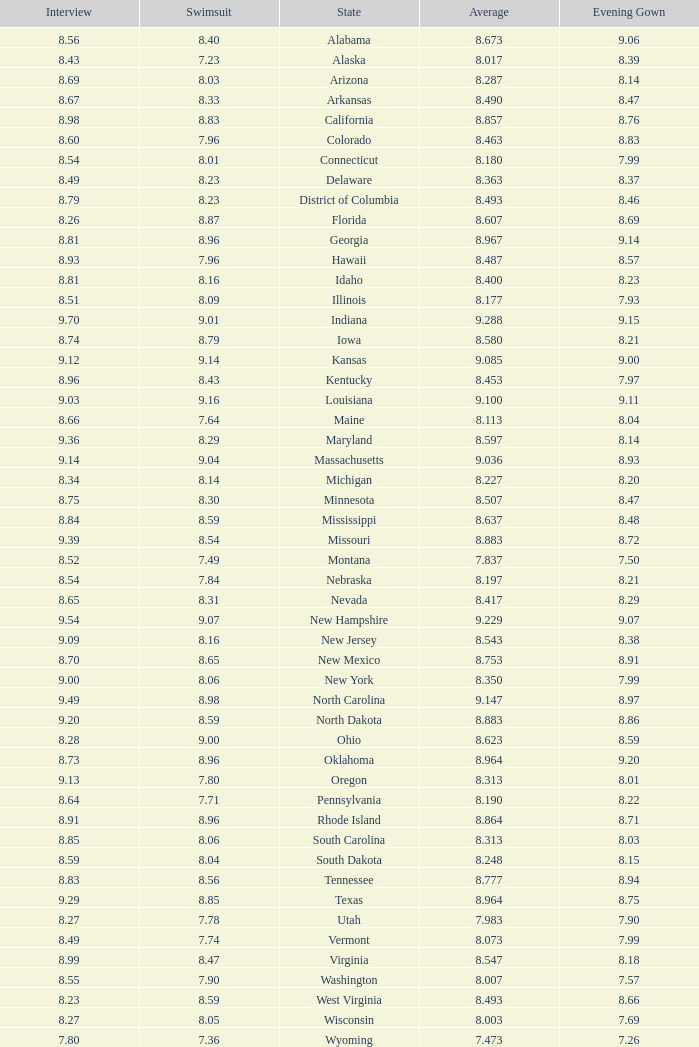Name the total number of swimsuits for evening gowns less than 8.21 and average of 8.453 with interview less than 9.09 1.0. 